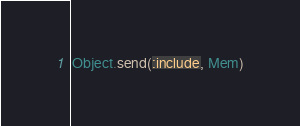Convert code to text. <code><loc_0><loc_0><loc_500><loc_500><_Ruby_>Object.send(:include, Mem)
</code> 